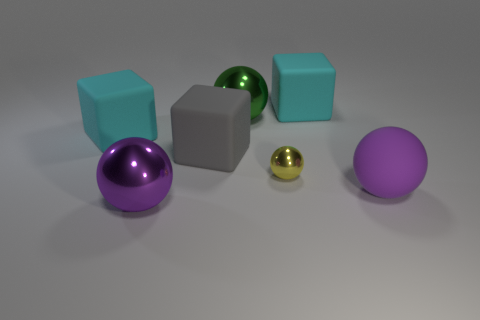What number of other objects are the same size as the green metal thing?
Provide a succinct answer. 5. What number of things are either cyan rubber objects that are to the right of the big purple shiny ball or tiny metallic things?
Offer a very short reply. 2. What is the color of the tiny metallic object?
Provide a succinct answer. Yellow. What is the material of the big purple thing that is to the right of the gray rubber object?
Ensure brevity in your answer.  Rubber. Is the shape of the purple matte thing the same as the yellow thing in front of the large gray rubber thing?
Offer a very short reply. Yes. Are there more tiny blue metallic objects than big objects?
Provide a short and direct response. No. Is there anything else that has the same color as the small sphere?
Provide a short and direct response. No. What shape is the purple object that is the same material as the yellow thing?
Your response must be concise. Sphere. There is a cyan object that is to the left of the large metallic ball that is to the right of the gray cube; what is its material?
Your response must be concise. Rubber. There is a large metal object that is on the right side of the purple metallic ball; is its shape the same as the purple shiny thing?
Make the answer very short. Yes. 